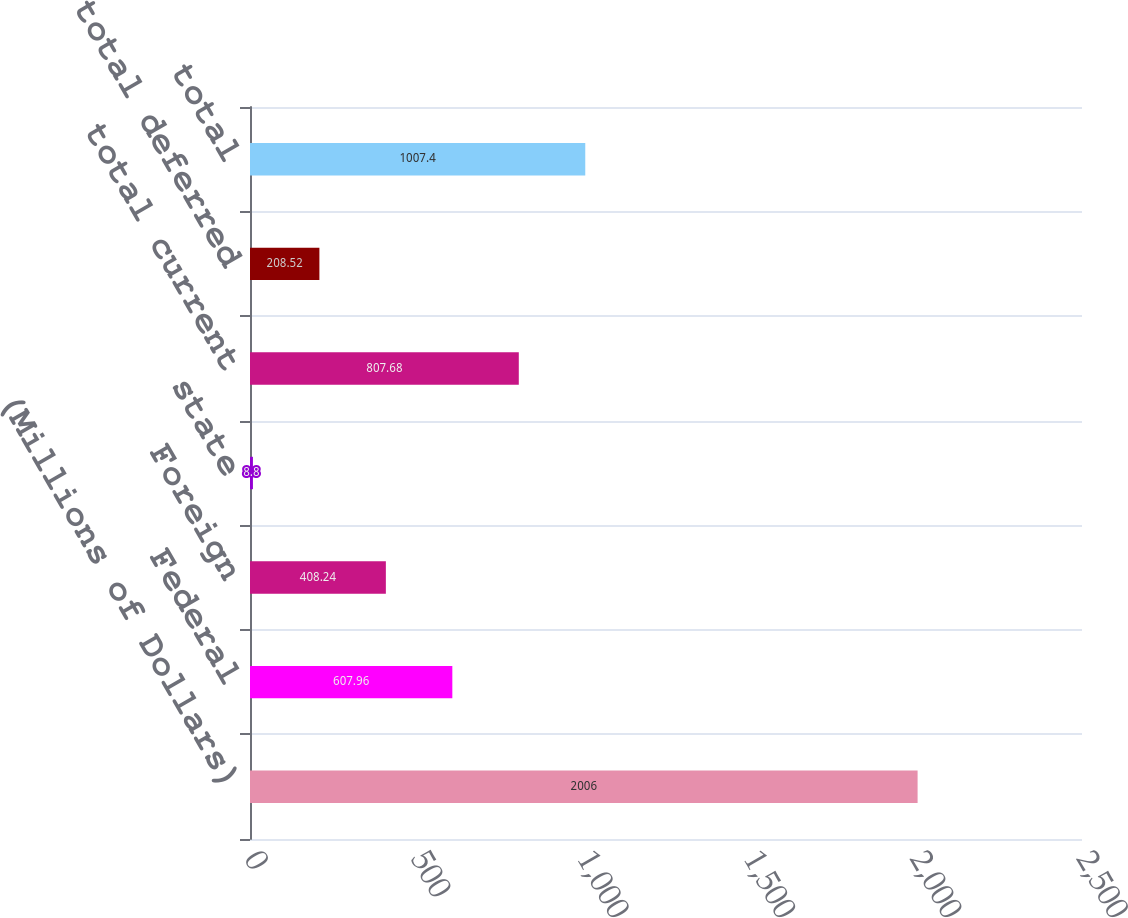Convert chart to OTSL. <chart><loc_0><loc_0><loc_500><loc_500><bar_chart><fcel>(Millions of Dollars)<fcel>Federal<fcel>Foreign<fcel>state<fcel>total current<fcel>total deferred<fcel>total<nl><fcel>2006<fcel>607.96<fcel>408.24<fcel>8.8<fcel>807.68<fcel>208.52<fcel>1007.4<nl></chart> 